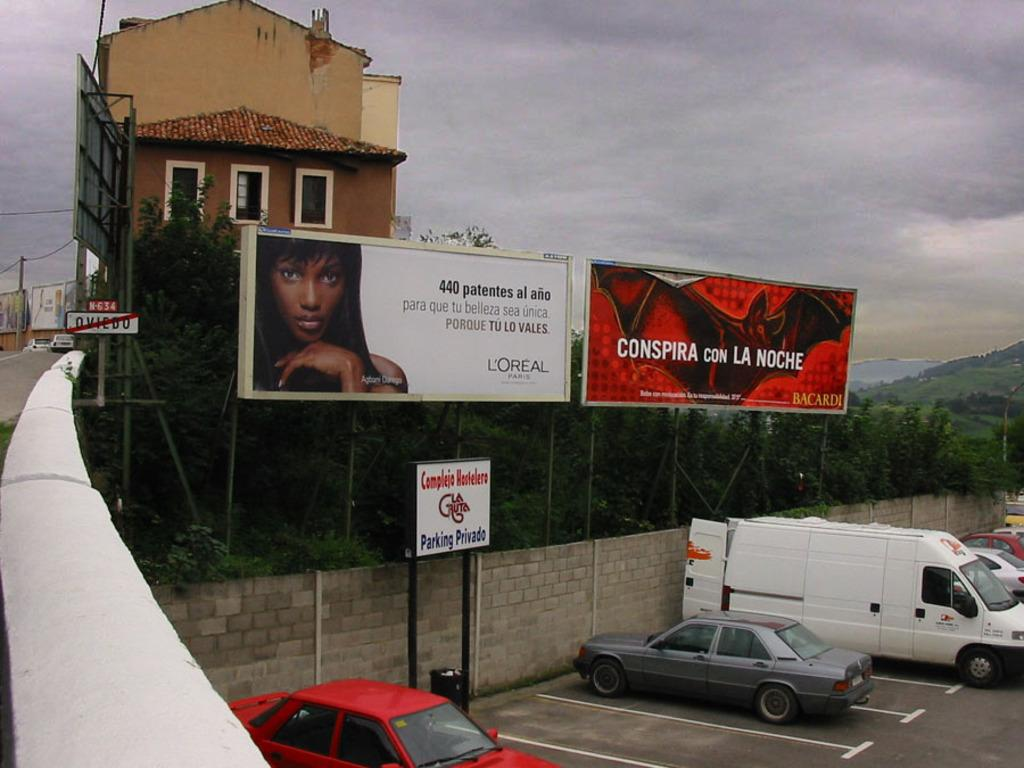Provide a one-sentence caption for the provided image. Two billboards, one for a cosmetics company, sit above a parking area and behind a house. 